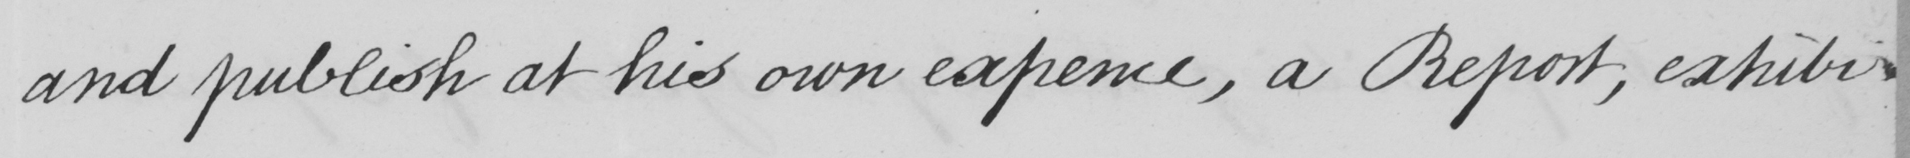Please transcribe the handwritten text in this image. and publish at his own expence , a Report , exhibi- 